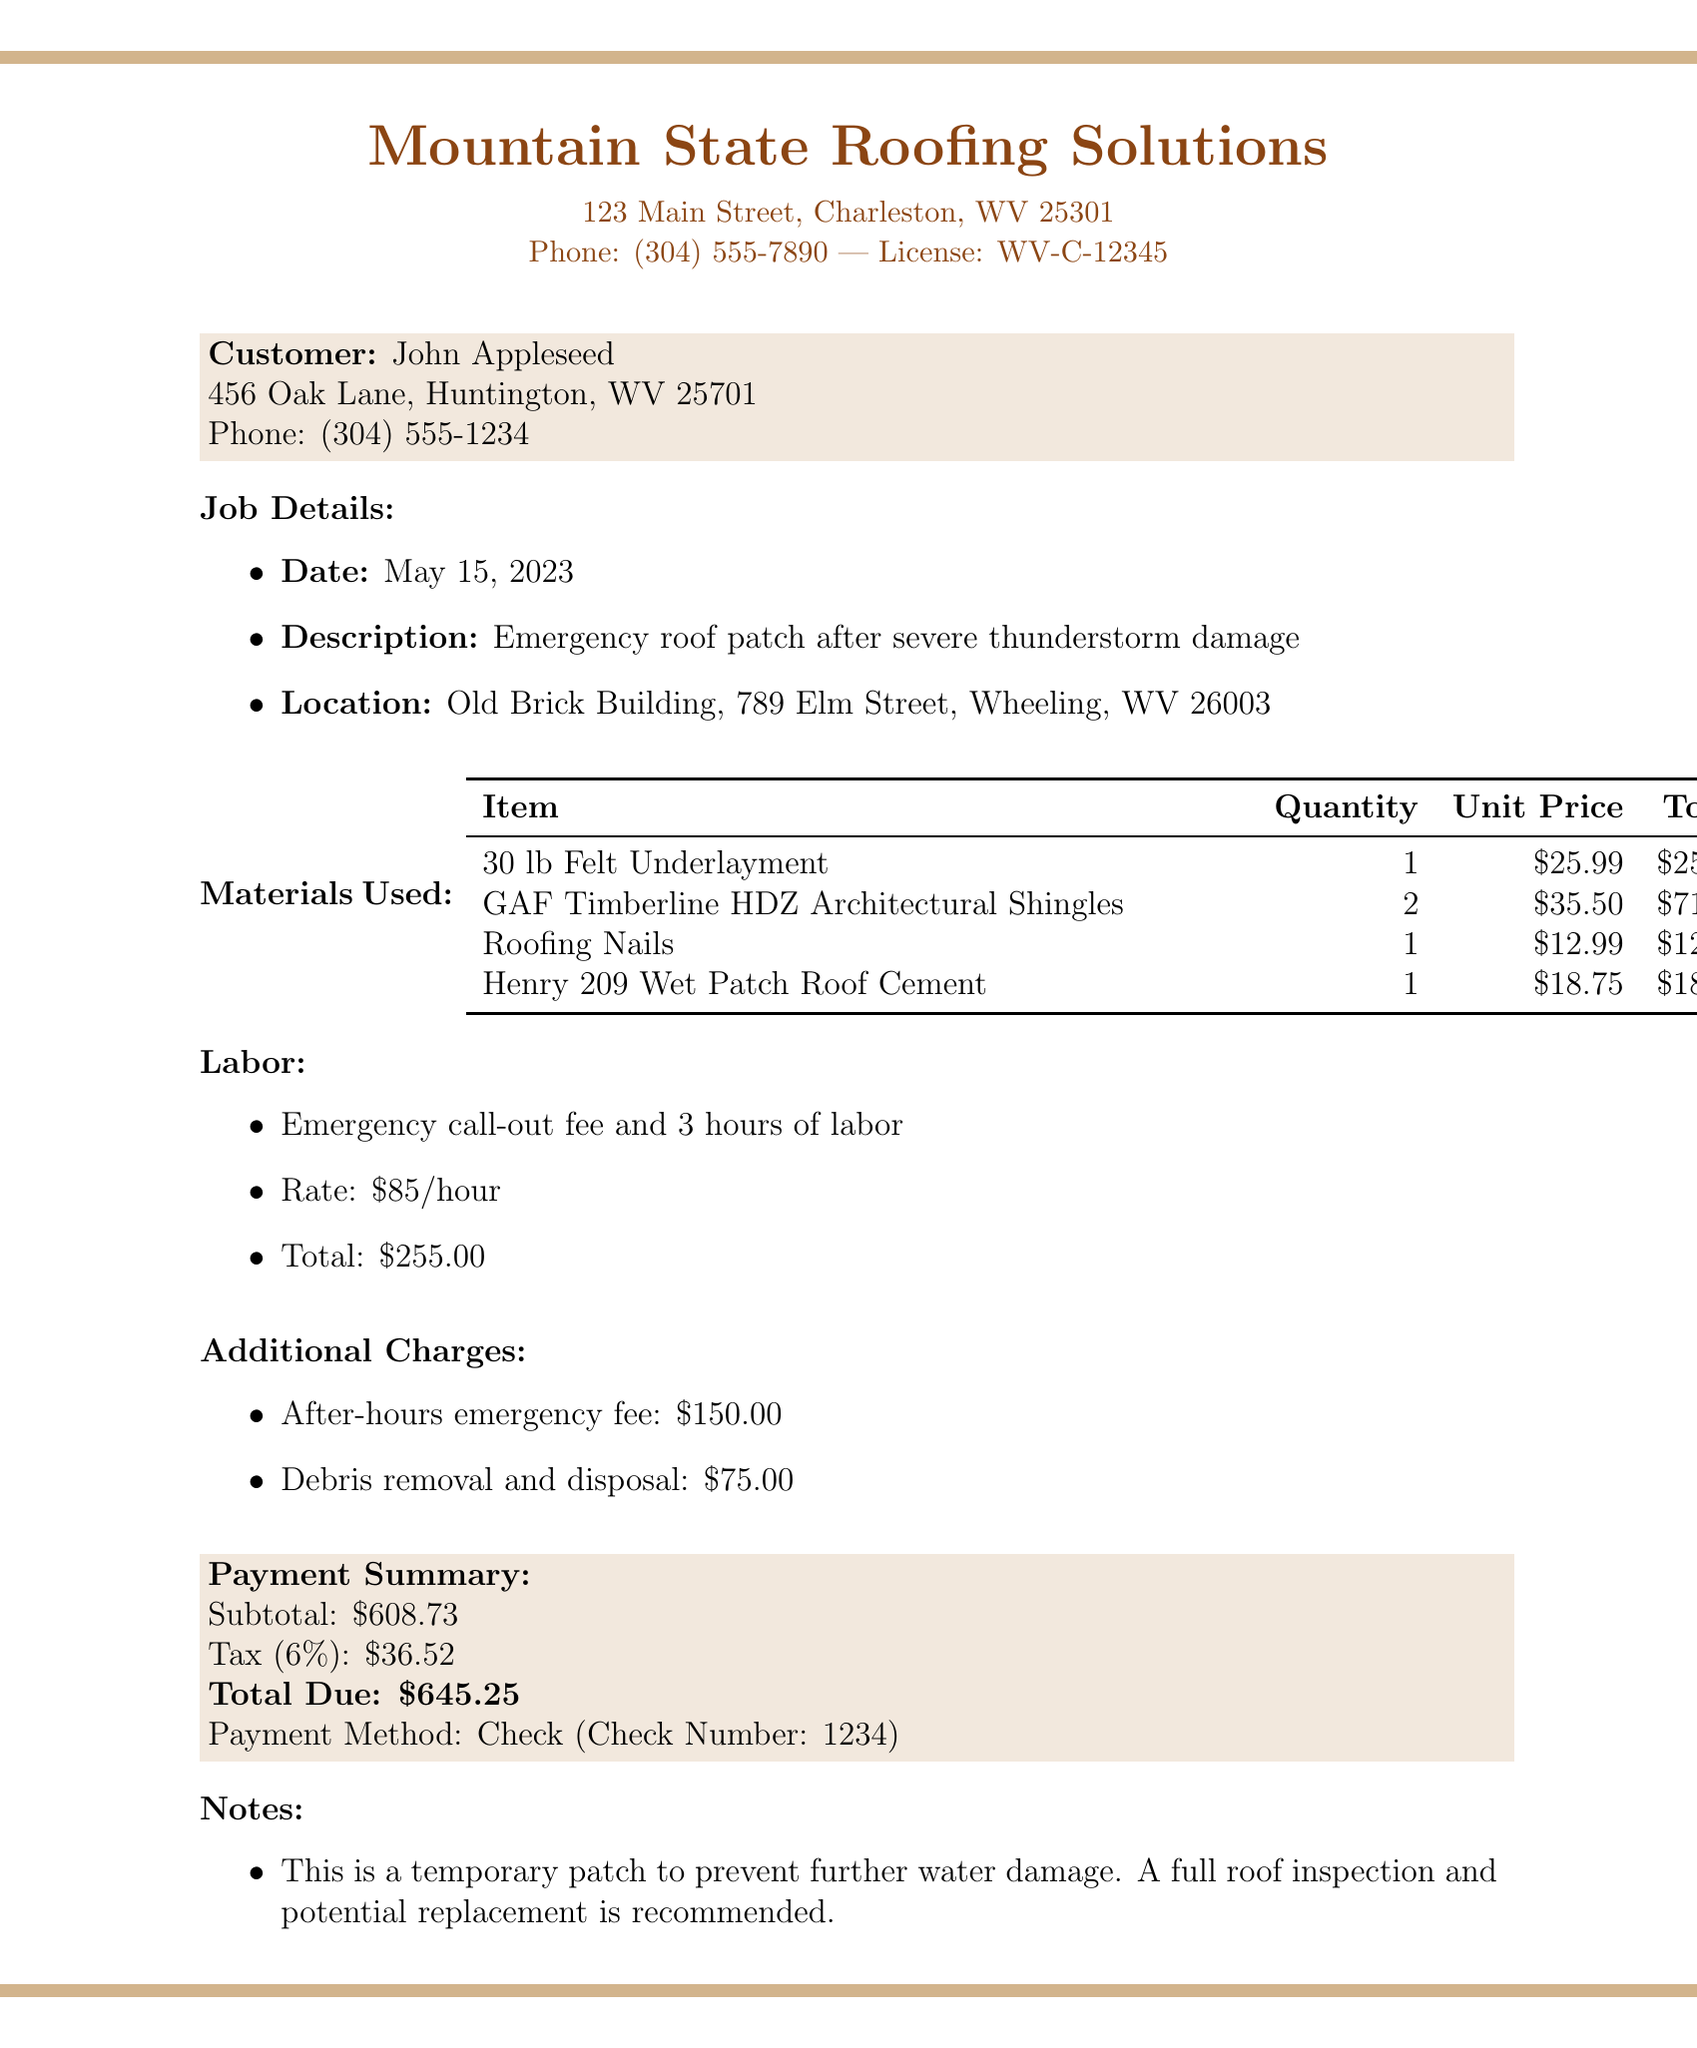What is the contractor's name? The contractor's name is located at the top of the document under contractor info.
Answer: Mountain State Roofing Solutions What is the total due for the services? The total due is mentioned in the payment summary section.
Answer: 645.25 What was the date of the job? The job date is specified in the job details section.
Answer: May 15, 2023 How many hours of labor were billed? The number of hours can be found under the labor section of the receipt.
Answer: 3 What is the warranty period on workmanship? The warranty information is included in the notes section of the document.
Answer: 30-day What item was used for roofing nails? The specific item name is listed under materials used.
Answer: Roofing Nails What was the emergency call-out fee? The emergency call-out fee is part of the labor description.
Answer: 255 What is the tax rate applied? The tax rate is mentioned in the payment summary section.
Answer: 6% Why is a full roof inspection recommended? The recommendation is noted in the notes section of the document.
Answer: To prevent further water damage 